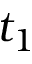<formula> <loc_0><loc_0><loc_500><loc_500>t _ { 1 }</formula> 